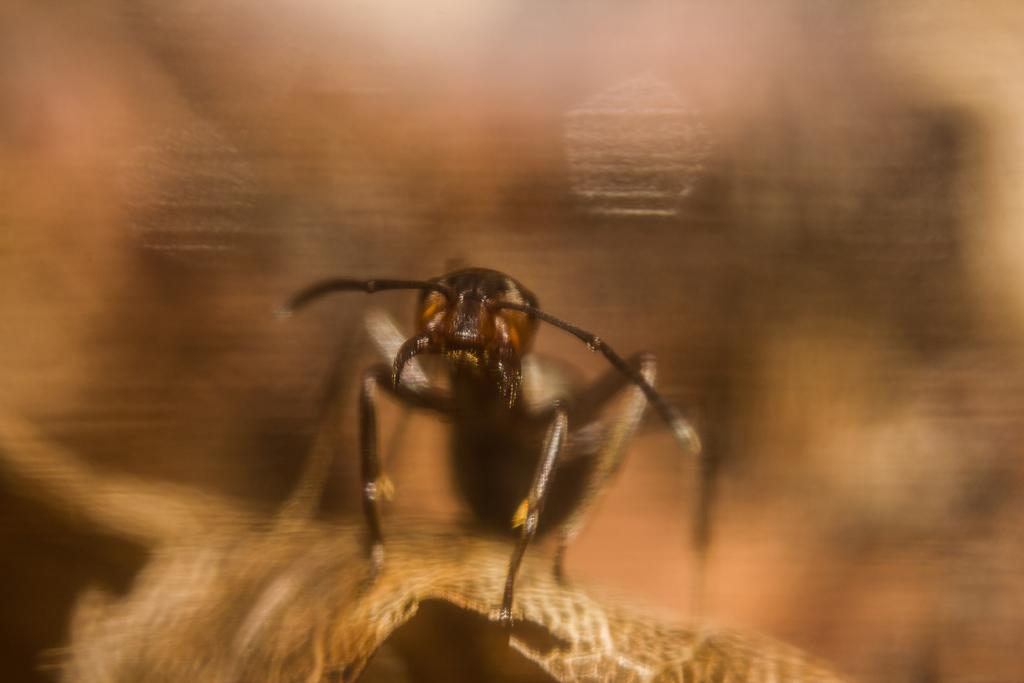What type of creature is present in the image? There is a black color insect in the image. What type of boat can be seen in the image? There is no boat present in the image; it features a black color insect. What songs are being sung by the insect in the image? Insects do not sing songs, and there is no indication of any songs being sung in the image. 